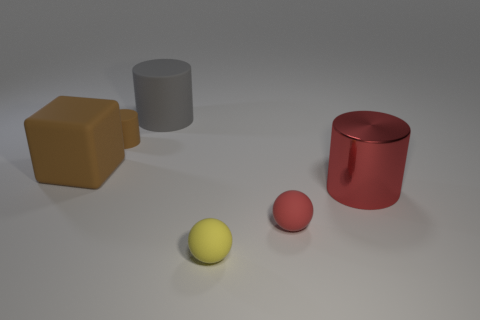Add 3 large purple objects. How many objects exist? 9 Subtract all cubes. How many objects are left? 5 Add 1 small red objects. How many small red objects exist? 2 Subtract 1 brown cubes. How many objects are left? 5 Subtract all red objects. Subtract all gray rubber cylinders. How many objects are left? 3 Add 5 big brown blocks. How many big brown blocks are left? 6 